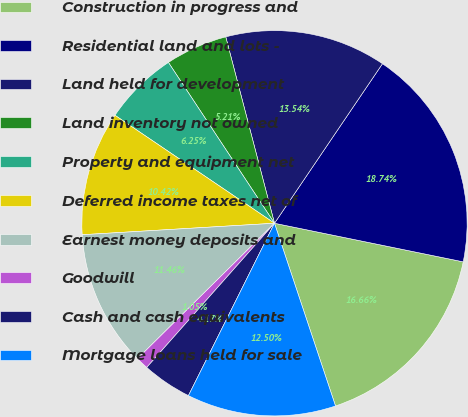Convert chart to OTSL. <chart><loc_0><loc_0><loc_500><loc_500><pie_chart><fcel>Construction in progress and<fcel>Residential land and lots -<fcel>Land held for development<fcel>Land inventory not owned<fcel>Property and equipment net<fcel>Deferred income taxes net of<fcel>Earnest money deposits and<fcel>Goodwill<fcel>Cash and cash equivalents<fcel>Mortgage loans held for sale<nl><fcel>16.66%<fcel>18.74%<fcel>13.54%<fcel>5.21%<fcel>6.25%<fcel>10.42%<fcel>11.46%<fcel>1.05%<fcel>4.17%<fcel>12.5%<nl></chart> 